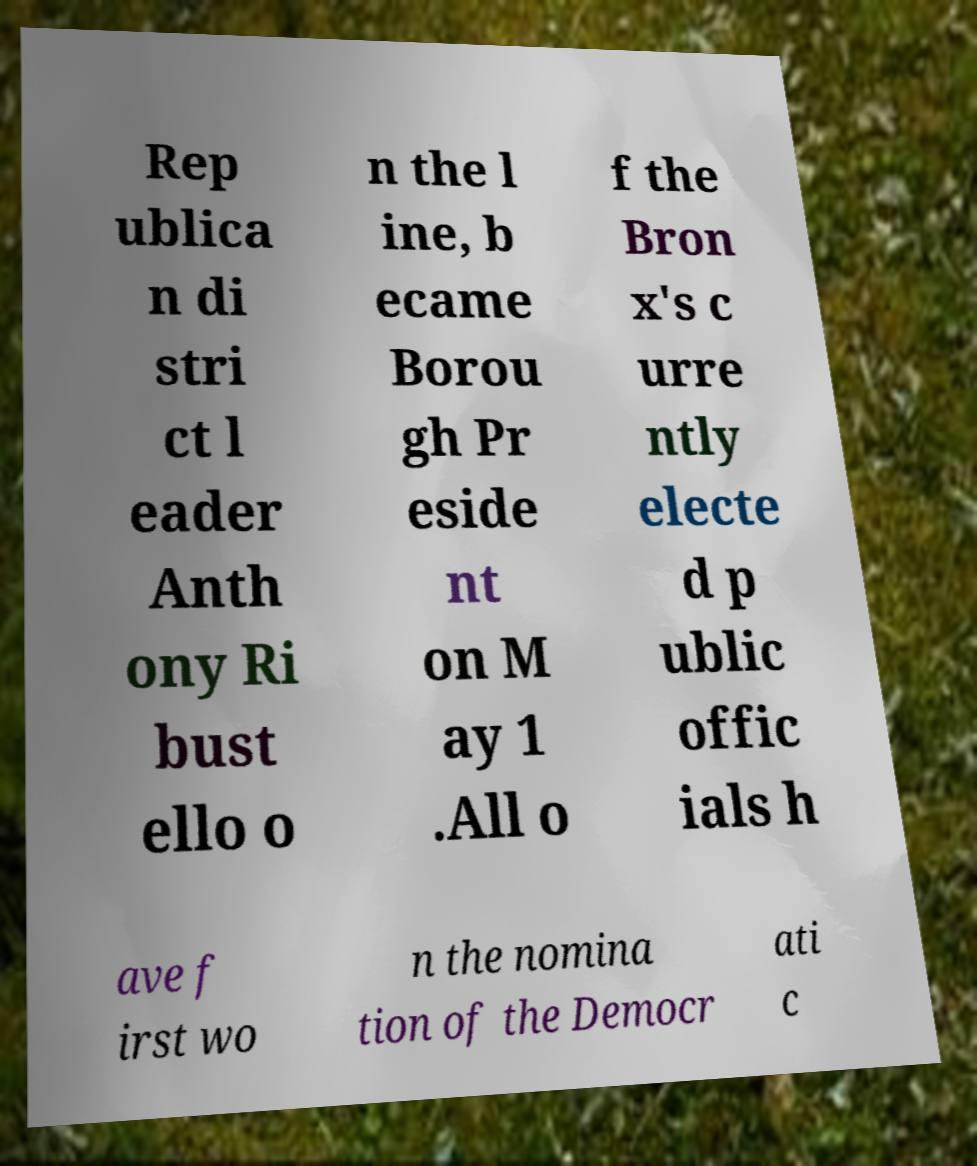Can you accurately transcribe the text from the provided image for me? Rep ublica n di stri ct l eader Anth ony Ri bust ello o n the l ine, b ecame Borou gh Pr eside nt on M ay 1 .All o f the Bron x's c urre ntly electe d p ublic offic ials h ave f irst wo n the nomina tion of the Democr ati c 